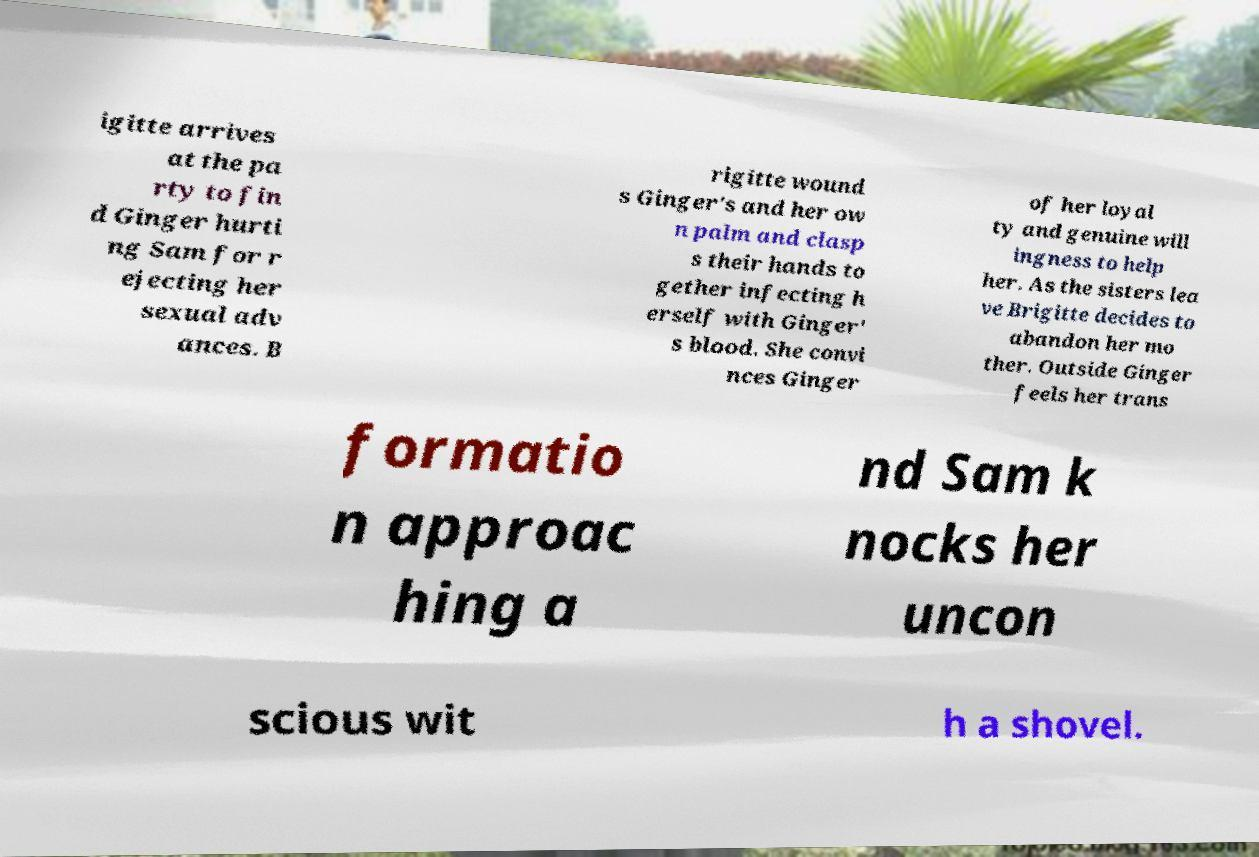Please read and relay the text visible in this image. What does it say? igitte arrives at the pa rty to fin d Ginger hurti ng Sam for r ejecting her sexual adv ances. B rigitte wound s Ginger's and her ow n palm and clasp s their hands to gether infecting h erself with Ginger' s blood. She convi nces Ginger of her loyal ty and genuine will ingness to help her. As the sisters lea ve Brigitte decides to abandon her mo ther. Outside Ginger feels her trans formatio n approac hing a nd Sam k nocks her uncon scious wit h a shovel. 